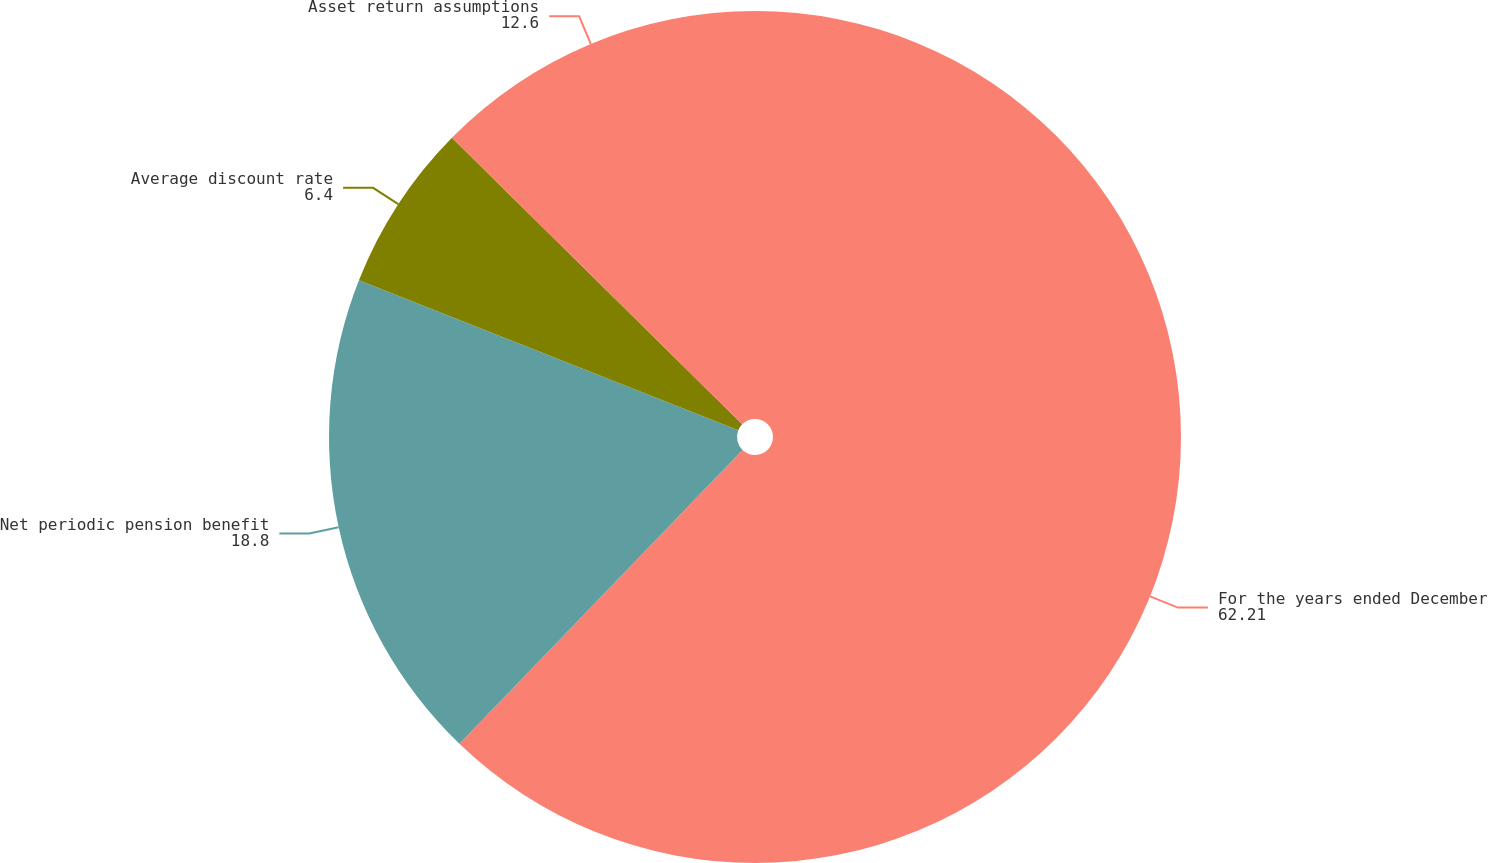Convert chart to OTSL. <chart><loc_0><loc_0><loc_500><loc_500><pie_chart><fcel>For the years ended December<fcel>Net periodic pension benefit<fcel>Average discount rate<fcel>Asset return assumptions<nl><fcel>62.21%<fcel>18.8%<fcel>6.4%<fcel>12.6%<nl></chart> 